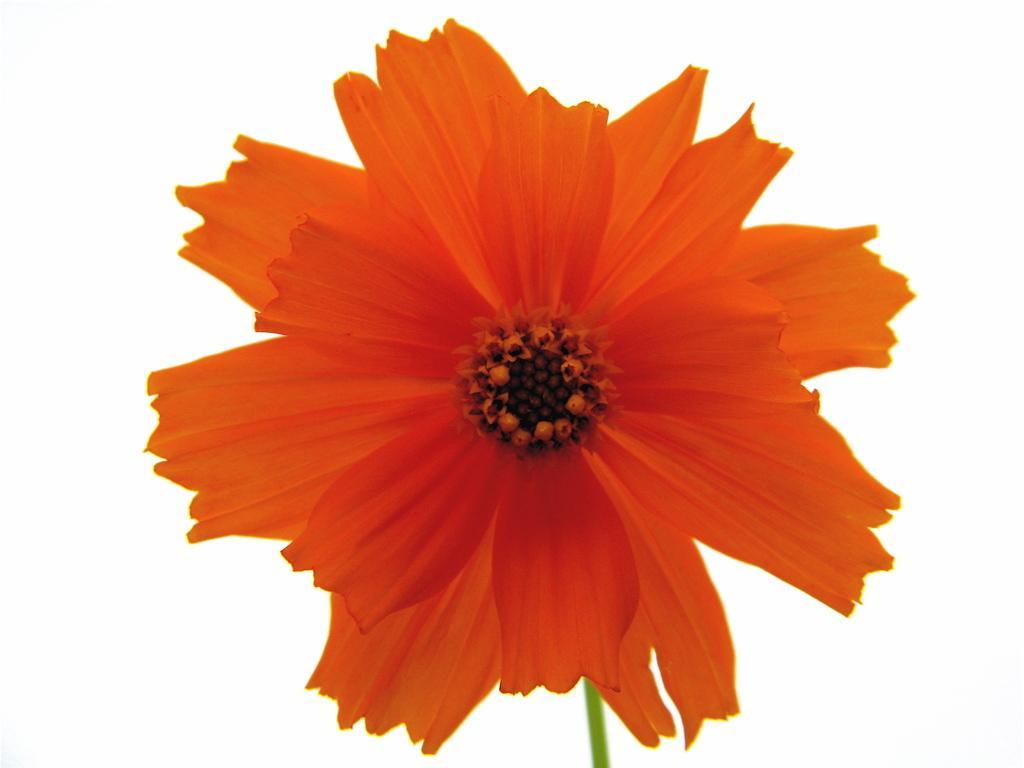Could you give a brief overview of what you see in this image? In the image I can see an orange color flower. The background of the image is white in color. 